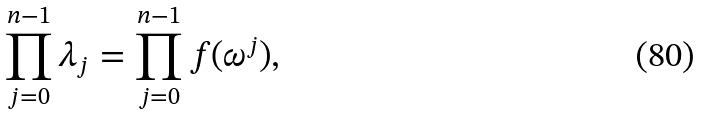<formula> <loc_0><loc_0><loc_500><loc_500>\prod _ { j = 0 } ^ { n - 1 } \lambda _ { j } = \prod _ { j = 0 } ^ { n - 1 } f ( \omega ^ { j } ) ,</formula> 